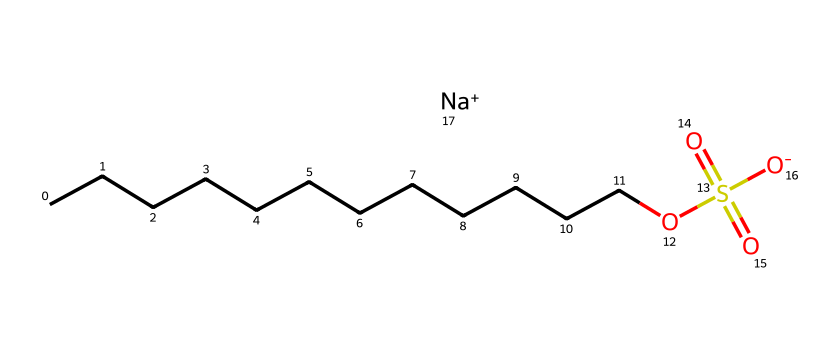What is the common name of this chemical? The chemical represented by the SMILES notation is sodium dodecyl sulfate, which is a widely used anionic surfactant. The long hydrocarbon chain (dodecyl) indicates that it is a type of detergent.
Answer: sodium dodecyl sulfate How many carbon atoms are in sodium dodecyl sulfate? Counting the "C" atoms in the hydrocarbon chain (CCCCCCCCCCCC), there are 12 carbon atoms in total. The "Na" does not contribute to the carbon count.
Answer: 12 What type of functional group is present in sodium dodecyl sulfate? The presence of the structure "OS(=O)(=O)[O-]" indicates a sulfonate functional group, which characterizes this molecule as a surfactant. This group is essential for its properties as a detergent.
Answer: sulfonate What is the charge of the sulfate group in sodium dodecyl sulfate? The "OS(=O)(=O)[O-]" part reveals that one of the oxygen atoms has a negative charge (the [O-]), giving the sulfate group a net negative charge.
Answer: negative What makes sodium dodecyl sulfate an effective surfactant? The long hydrophobic hydrocarbon chain (dodecyl) allows it to interact with oils and grease, while the hydrophilic sulfate group interacts with water, reducing surface tension and enabling cleaning.
Answer: hydrophilic and hydrophobic regions What is the role of the sodium ion in sodium dodecyl sulfate? The sodium ion (Na+) acts to balance the charge of the negatively charged sulfate group, ensuring the overall stability and solubility of the molecule in water.
Answer: charge balance 